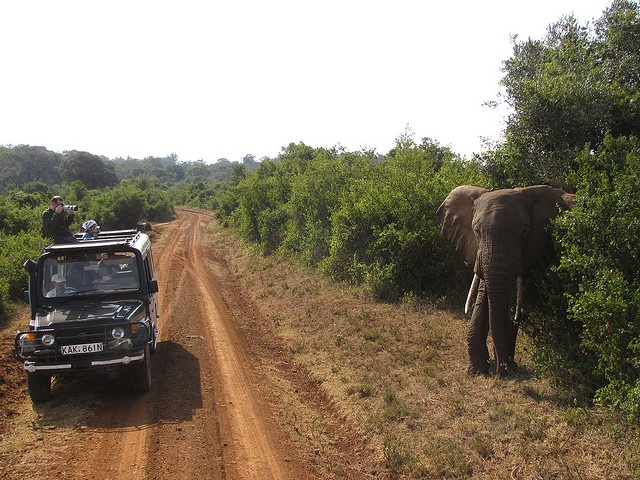Describe the objects in this image and their specific colors. I can see truck in white, black, gray, and darkgray tones, elephant in white, black, and gray tones, people in white, black, gray, and darkgreen tones, people in white, gray, and black tones, and people in white, gray, black, lavender, and darkgray tones in this image. 